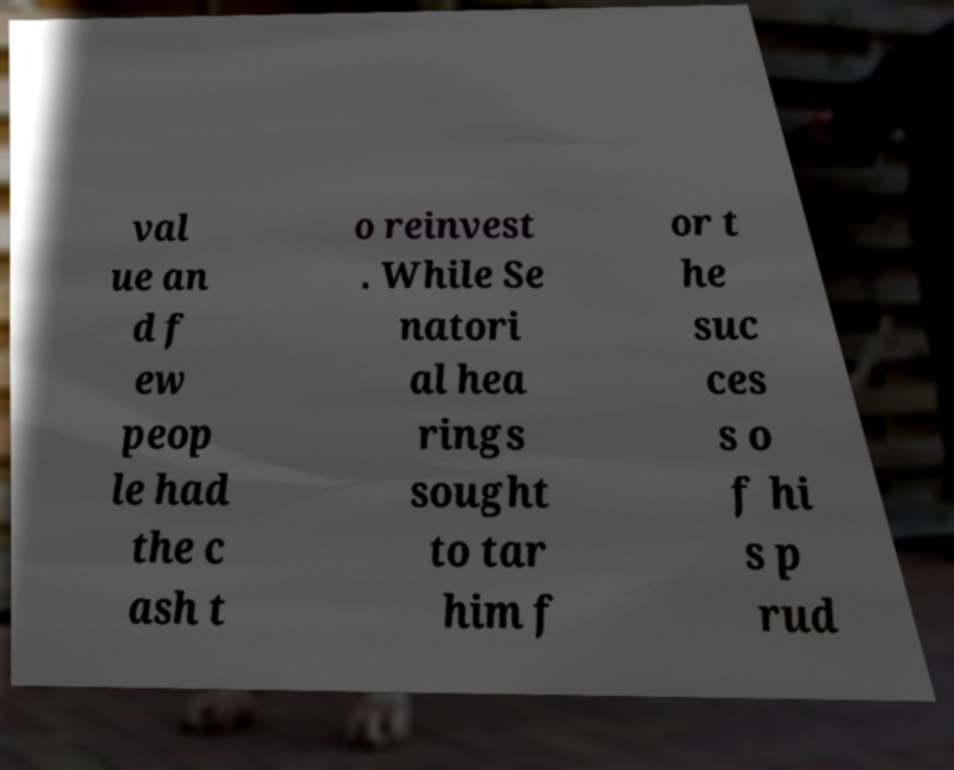Could you extract and type out the text from this image? val ue an d f ew peop le had the c ash t o reinvest . While Se natori al hea rings sought to tar him f or t he suc ces s o f hi s p rud 